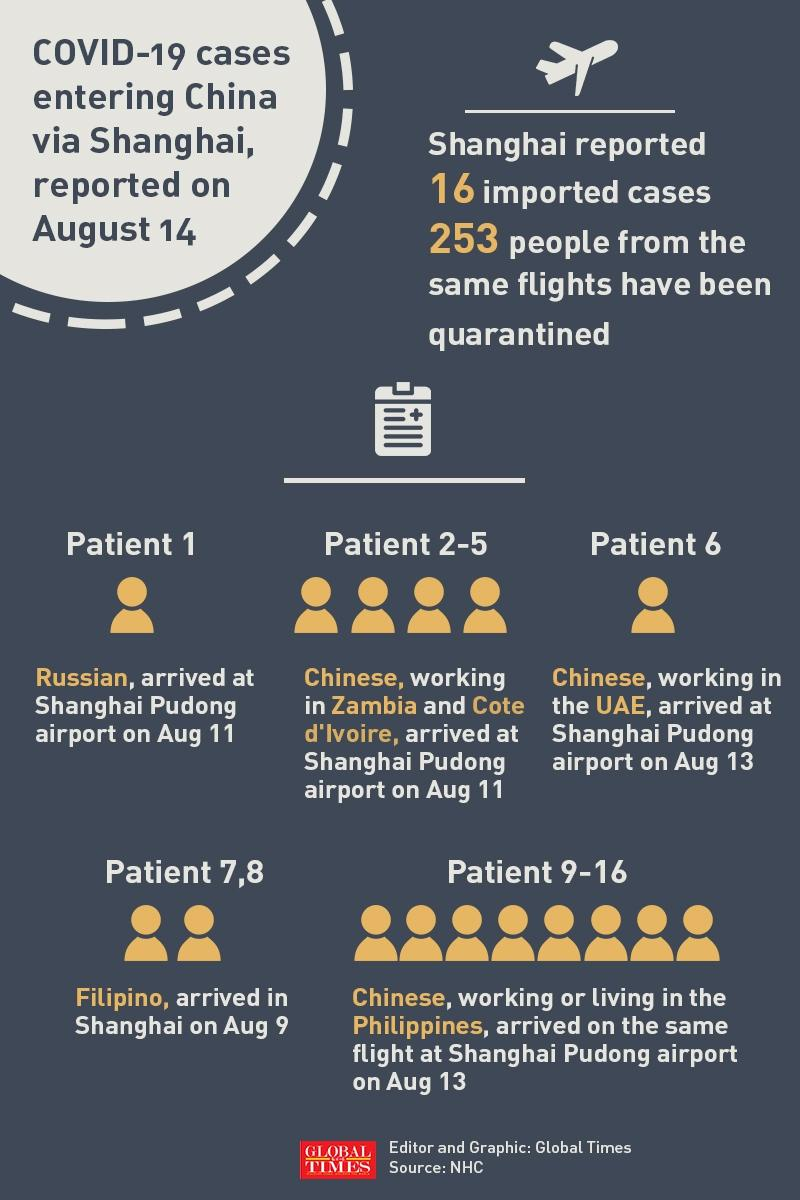Point out several critical features in this image. Patient number 6 was working in the United Arab Emirates. Patient 1 arrived on August 11. Patient 7 and 8 were Filipino nationals. The following patients arrived on August 9th: Patient 7 and Patient 8. The first imported case of COVID-19 in Shanghai was a Russian national. 